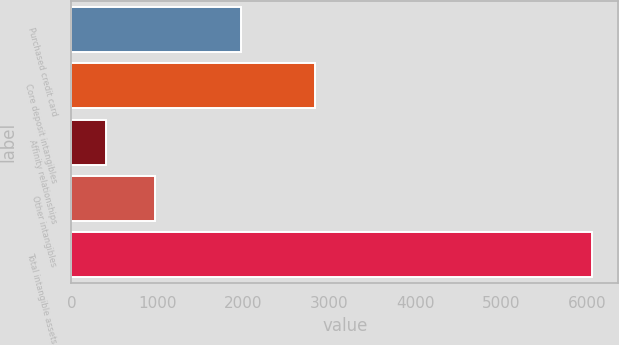Convert chart. <chart><loc_0><loc_0><loc_500><loc_500><bar_chart><fcel>Purchased credit card<fcel>Core deposit intangibles<fcel>Affinity relationships<fcel>Other intangibles<fcel>Total intangible assets<nl><fcel>1970<fcel>2828<fcel>406<fcel>971<fcel>6056<nl></chart> 